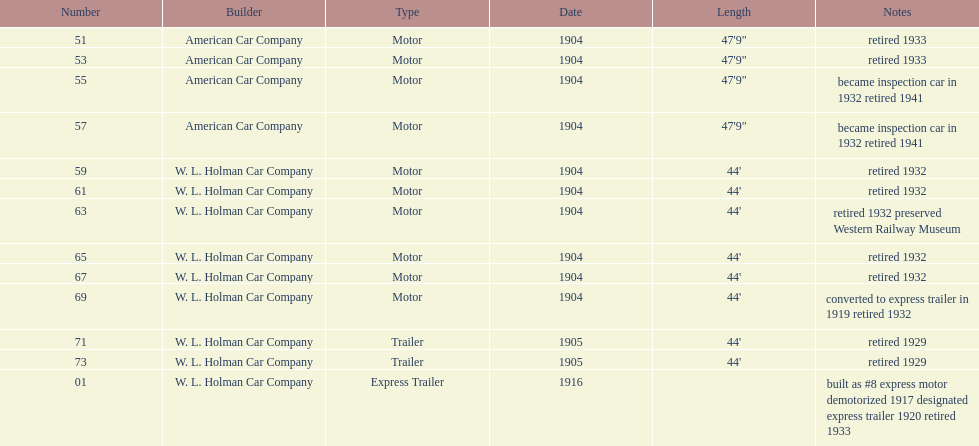For how long did number 71 work before retirement? 24. 